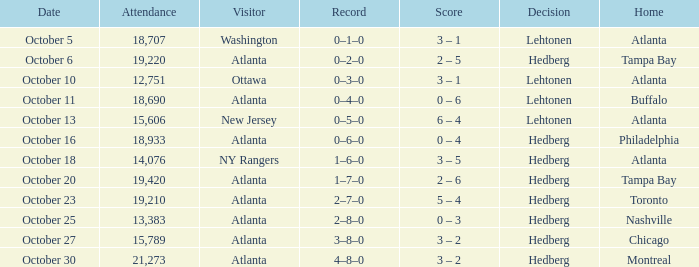What was the record on the game that was played on october 27? 3–8–0. 